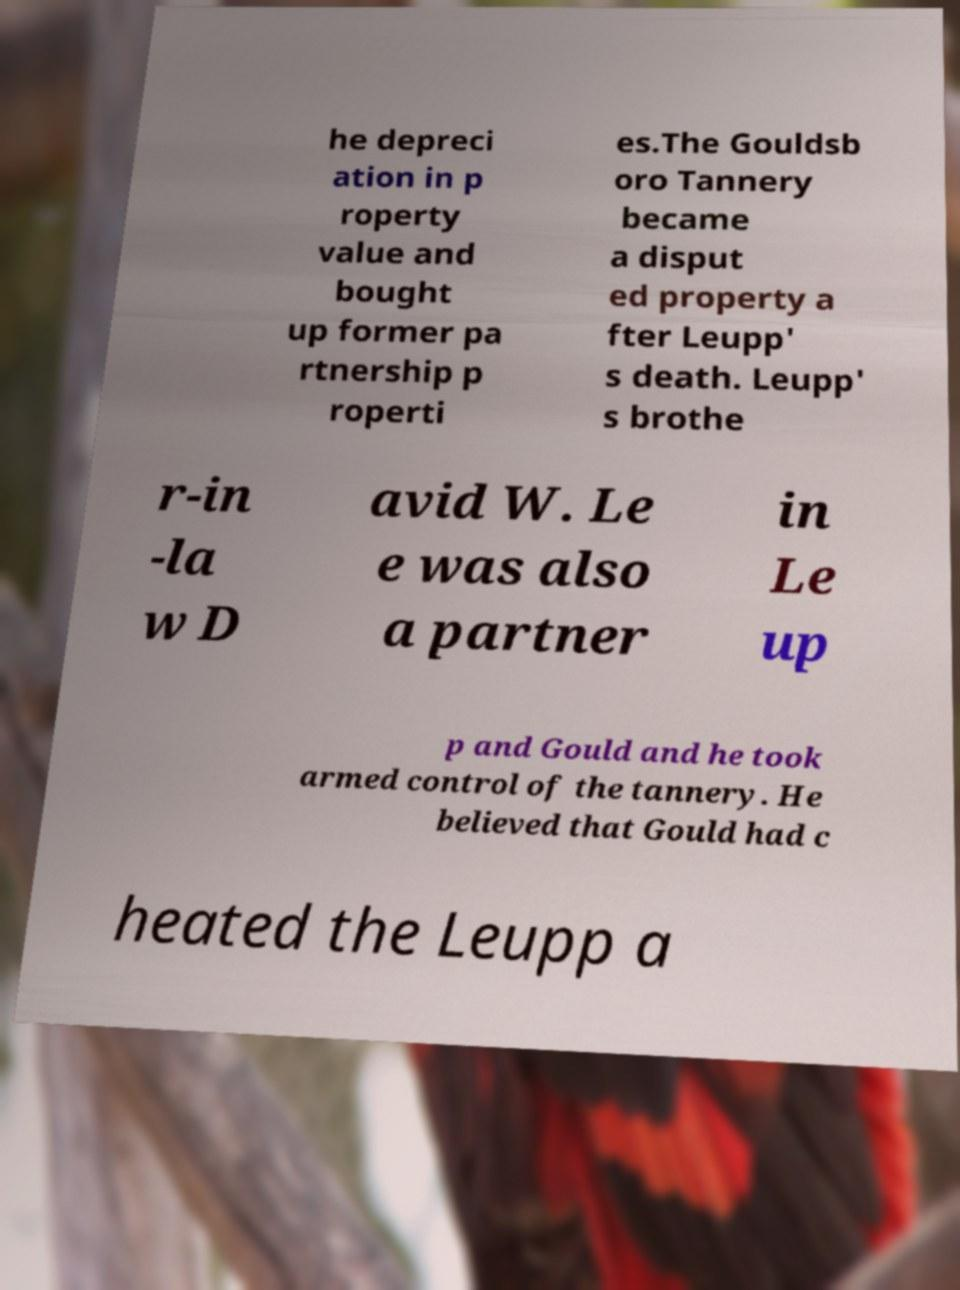There's text embedded in this image that I need extracted. Can you transcribe it verbatim? he depreci ation in p roperty value and bought up former pa rtnership p roperti es.The Gouldsb oro Tannery became a disput ed property a fter Leupp' s death. Leupp' s brothe r-in -la w D avid W. Le e was also a partner in Le up p and Gould and he took armed control of the tannery. He believed that Gould had c heated the Leupp a 